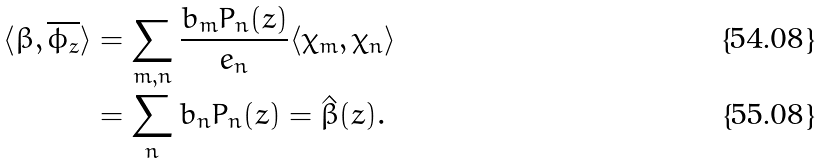<formula> <loc_0><loc_0><loc_500><loc_500>\langle \beta , \overline { \phi _ { z } } \rangle & = \sum _ { m , n } \frac { b _ { m } P _ { n } ( z ) } { e _ { n } } \langle \chi _ { m } , \chi _ { n } \rangle \\ & = \sum _ { n } b _ { n } P _ { n } ( z ) = \hat { \beta } ( z ) .</formula> 